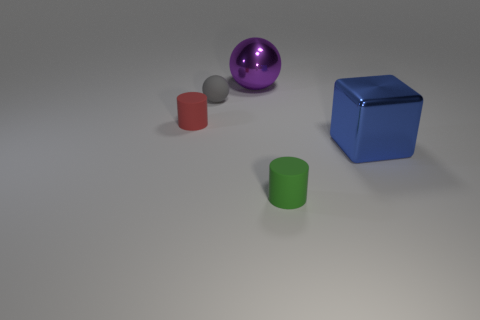Add 1 big brown cylinders. How many objects exist? 6 Subtract all cubes. How many objects are left? 4 Subtract all blue metallic blocks. Subtract all spheres. How many objects are left? 2 Add 5 small objects. How many small objects are left? 8 Add 1 gray rubber objects. How many gray rubber objects exist? 2 Subtract 0 green balls. How many objects are left? 5 